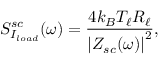<formula> <loc_0><loc_0><loc_500><loc_500>S _ { I _ { l o a d } } ^ { s c } ( \omega ) = \frac { 4 k _ { B } T _ { \ell } R _ { \ell } } { \left | Z _ { s c } ( \omega ) \right | ^ { 2 } } ,</formula> 